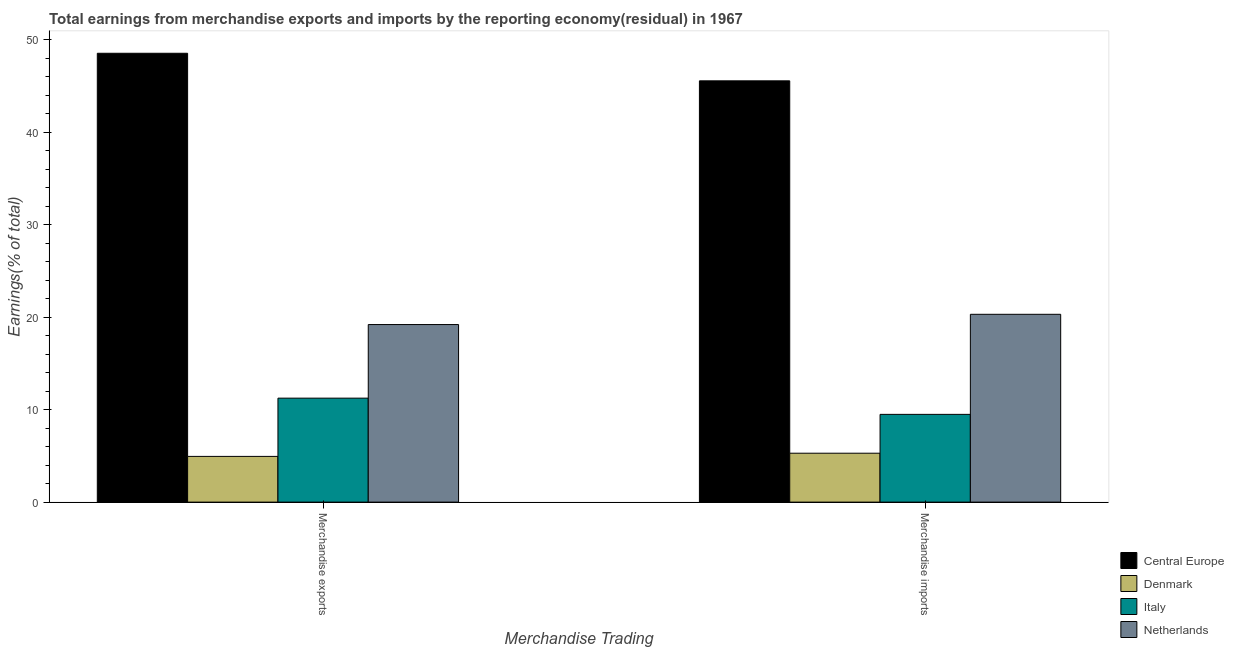How many different coloured bars are there?
Your response must be concise. 4. How many groups of bars are there?
Provide a succinct answer. 2. Are the number of bars per tick equal to the number of legend labels?
Your response must be concise. Yes. Are the number of bars on each tick of the X-axis equal?
Offer a terse response. Yes. How many bars are there on the 2nd tick from the right?
Provide a succinct answer. 4. What is the label of the 1st group of bars from the left?
Your answer should be compact. Merchandise exports. What is the earnings from merchandise imports in Central Europe?
Your response must be concise. 45.56. Across all countries, what is the maximum earnings from merchandise exports?
Provide a short and direct response. 48.54. Across all countries, what is the minimum earnings from merchandise imports?
Your answer should be compact. 5.29. In which country was the earnings from merchandise exports maximum?
Your response must be concise. Central Europe. What is the total earnings from merchandise imports in the graph?
Your response must be concise. 80.65. What is the difference between the earnings from merchandise imports in Denmark and that in Central Europe?
Your answer should be compact. -40.27. What is the difference between the earnings from merchandise imports in Central Europe and the earnings from merchandise exports in Denmark?
Your answer should be very brief. 40.61. What is the average earnings from merchandise exports per country?
Your response must be concise. 20.98. What is the difference between the earnings from merchandise exports and earnings from merchandise imports in Central Europe?
Offer a very short reply. 2.98. In how many countries, is the earnings from merchandise imports greater than 24 %?
Offer a very short reply. 1. What is the ratio of the earnings from merchandise imports in Central Europe to that in Italy?
Give a very brief answer. 4.8. Is the earnings from merchandise exports in Central Europe less than that in Denmark?
Provide a short and direct response. No. In how many countries, is the earnings from merchandise imports greater than the average earnings from merchandise imports taken over all countries?
Give a very brief answer. 2. What does the 1st bar from the left in Merchandise exports represents?
Your answer should be very brief. Central Europe. How many bars are there?
Your response must be concise. 8. What is the difference between two consecutive major ticks on the Y-axis?
Provide a succinct answer. 10. Are the values on the major ticks of Y-axis written in scientific E-notation?
Provide a succinct answer. No. Does the graph contain any zero values?
Your answer should be compact. No. How are the legend labels stacked?
Your response must be concise. Vertical. What is the title of the graph?
Offer a terse response. Total earnings from merchandise exports and imports by the reporting economy(residual) in 1967. Does "Heavily indebted poor countries" appear as one of the legend labels in the graph?
Offer a very short reply. No. What is the label or title of the X-axis?
Keep it short and to the point. Merchandise Trading. What is the label or title of the Y-axis?
Provide a succinct answer. Earnings(% of total). What is the Earnings(% of total) of Central Europe in Merchandise exports?
Your answer should be compact. 48.54. What is the Earnings(% of total) of Denmark in Merchandise exports?
Offer a terse response. 4.94. What is the Earnings(% of total) in Italy in Merchandise exports?
Provide a short and direct response. 11.24. What is the Earnings(% of total) in Netherlands in Merchandise exports?
Your answer should be very brief. 19.2. What is the Earnings(% of total) in Central Europe in Merchandise imports?
Provide a succinct answer. 45.56. What is the Earnings(% of total) of Denmark in Merchandise imports?
Make the answer very short. 5.29. What is the Earnings(% of total) of Italy in Merchandise imports?
Offer a very short reply. 9.49. What is the Earnings(% of total) of Netherlands in Merchandise imports?
Provide a succinct answer. 20.31. Across all Merchandise Trading, what is the maximum Earnings(% of total) in Central Europe?
Ensure brevity in your answer.  48.54. Across all Merchandise Trading, what is the maximum Earnings(% of total) of Denmark?
Provide a succinct answer. 5.29. Across all Merchandise Trading, what is the maximum Earnings(% of total) of Italy?
Provide a short and direct response. 11.24. Across all Merchandise Trading, what is the maximum Earnings(% of total) of Netherlands?
Your answer should be very brief. 20.31. Across all Merchandise Trading, what is the minimum Earnings(% of total) in Central Europe?
Ensure brevity in your answer.  45.56. Across all Merchandise Trading, what is the minimum Earnings(% of total) in Denmark?
Provide a short and direct response. 4.94. Across all Merchandise Trading, what is the minimum Earnings(% of total) in Italy?
Your answer should be compact. 9.49. Across all Merchandise Trading, what is the minimum Earnings(% of total) of Netherlands?
Keep it short and to the point. 19.2. What is the total Earnings(% of total) in Central Europe in the graph?
Provide a succinct answer. 94.1. What is the total Earnings(% of total) in Denmark in the graph?
Offer a terse response. 10.23. What is the total Earnings(% of total) of Italy in the graph?
Give a very brief answer. 20.73. What is the total Earnings(% of total) of Netherlands in the graph?
Offer a terse response. 39.51. What is the difference between the Earnings(% of total) of Central Europe in Merchandise exports and that in Merchandise imports?
Make the answer very short. 2.98. What is the difference between the Earnings(% of total) in Denmark in Merchandise exports and that in Merchandise imports?
Provide a succinct answer. -0.34. What is the difference between the Earnings(% of total) in Italy in Merchandise exports and that in Merchandise imports?
Ensure brevity in your answer.  1.75. What is the difference between the Earnings(% of total) in Netherlands in Merchandise exports and that in Merchandise imports?
Offer a terse response. -1.11. What is the difference between the Earnings(% of total) of Central Europe in Merchandise exports and the Earnings(% of total) of Denmark in Merchandise imports?
Offer a very short reply. 43.25. What is the difference between the Earnings(% of total) in Central Europe in Merchandise exports and the Earnings(% of total) in Italy in Merchandise imports?
Keep it short and to the point. 39.05. What is the difference between the Earnings(% of total) of Central Europe in Merchandise exports and the Earnings(% of total) of Netherlands in Merchandise imports?
Keep it short and to the point. 28.23. What is the difference between the Earnings(% of total) in Denmark in Merchandise exports and the Earnings(% of total) in Italy in Merchandise imports?
Your response must be concise. -4.55. What is the difference between the Earnings(% of total) of Denmark in Merchandise exports and the Earnings(% of total) of Netherlands in Merchandise imports?
Your response must be concise. -15.37. What is the difference between the Earnings(% of total) of Italy in Merchandise exports and the Earnings(% of total) of Netherlands in Merchandise imports?
Keep it short and to the point. -9.07. What is the average Earnings(% of total) of Central Europe per Merchandise Trading?
Make the answer very short. 47.05. What is the average Earnings(% of total) of Denmark per Merchandise Trading?
Ensure brevity in your answer.  5.12. What is the average Earnings(% of total) of Italy per Merchandise Trading?
Provide a succinct answer. 10.37. What is the average Earnings(% of total) of Netherlands per Merchandise Trading?
Make the answer very short. 19.76. What is the difference between the Earnings(% of total) of Central Europe and Earnings(% of total) of Denmark in Merchandise exports?
Make the answer very short. 43.59. What is the difference between the Earnings(% of total) in Central Europe and Earnings(% of total) in Italy in Merchandise exports?
Make the answer very short. 37.3. What is the difference between the Earnings(% of total) in Central Europe and Earnings(% of total) in Netherlands in Merchandise exports?
Offer a very short reply. 29.34. What is the difference between the Earnings(% of total) in Denmark and Earnings(% of total) in Italy in Merchandise exports?
Provide a short and direct response. -6.3. What is the difference between the Earnings(% of total) in Denmark and Earnings(% of total) in Netherlands in Merchandise exports?
Your answer should be very brief. -14.26. What is the difference between the Earnings(% of total) of Italy and Earnings(% of total) of Netherlands in Merchandise exports?
Your answer should be very brief. -7.96. What is the difference between the Earnings(% of total) in Central Europe and Earnings(% of total) in Denmark in Merchandise imports?
Give a very brief answer. 40.27. What is the difference between the Earnings(% of total) of Central Europe and Earnings(% of total) of Italy in Merchandise imports?
Provide a succinct answer. 36.07. What is the difference between the Earnings(% of total) in Central Europe and Earnings(% of total) in Netherlands in Merchandise imports?
Ensure brevity in your answer.  25.25. What is the difference between the Earnings(% of total) in Denmark and Earnings(% of total) in Italy in Merchandise imports?
Keep it short and to the point. -4.2. What is the difference between the Earnings(% of total) of Denmark and Earnings(% of total) of Netherlands in Merchandise imports?
Your answer should be very brief. -15.02. What is the difference between the Earnings(% of total) in Italy and Earnings(% of total) in Netherlands in Merchandise imports?
Your answer should be compact. -10.82. What is the ratio of the Earnings(% of total) of Central Europe in Merchandise exports to that in Merchandise imports?
Provide a succinct answer. 1.07. What is the ratio of the Earnings(% of total) of Denmark in Merchandise exports to that in Merchandise imports?
Offer a very short reply. 0.93. What is the ratio of the Earnings(% of total) in Italy in Merchandise exports to that in Merchandise imports?
Give a very brief answer. 1.18. What is the ratio of the Earnings(% of total) in Netherlands in Merchandise exports to that in Merchandise imports?
Your response must be concise. 0.95. What is the difference between the highest and the second highest Earnings(% of total) in Central Europe?
Your answer should be very brief. 2.98. What is the difference between the highest and the second highest Earnings(% of total) in Denmark?
Your answer should be very brief. 0.34. What is the difference between the highest and the second highest Earnings(% of total) of Italy?
Your answer should be compact. 1.75. What is the difference between the highest and the second highest Earnings(% of total) in Netherlands?
Offer a terse response. 1.11. What is the difference between the highest and the lowest Earnings(% of total) of Central Europe?
Offer a terse response. 2.98. What is the difference between the highest and the lowest Earnings(% of total) in Denmark?
Provide a short and direct response. 0.34. What is the difference between the highest and the lowest Earnings(% of total) of Italy?
Keep it short and to the point. 1.75. What is the difference between the highest and the lowest Earnings(% of total) of Netherlands?
Give a very brief answer. 1.11. 